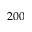<formula> <loc_0><loc_0><loc_500><loc_500>2 0 0</formula> 